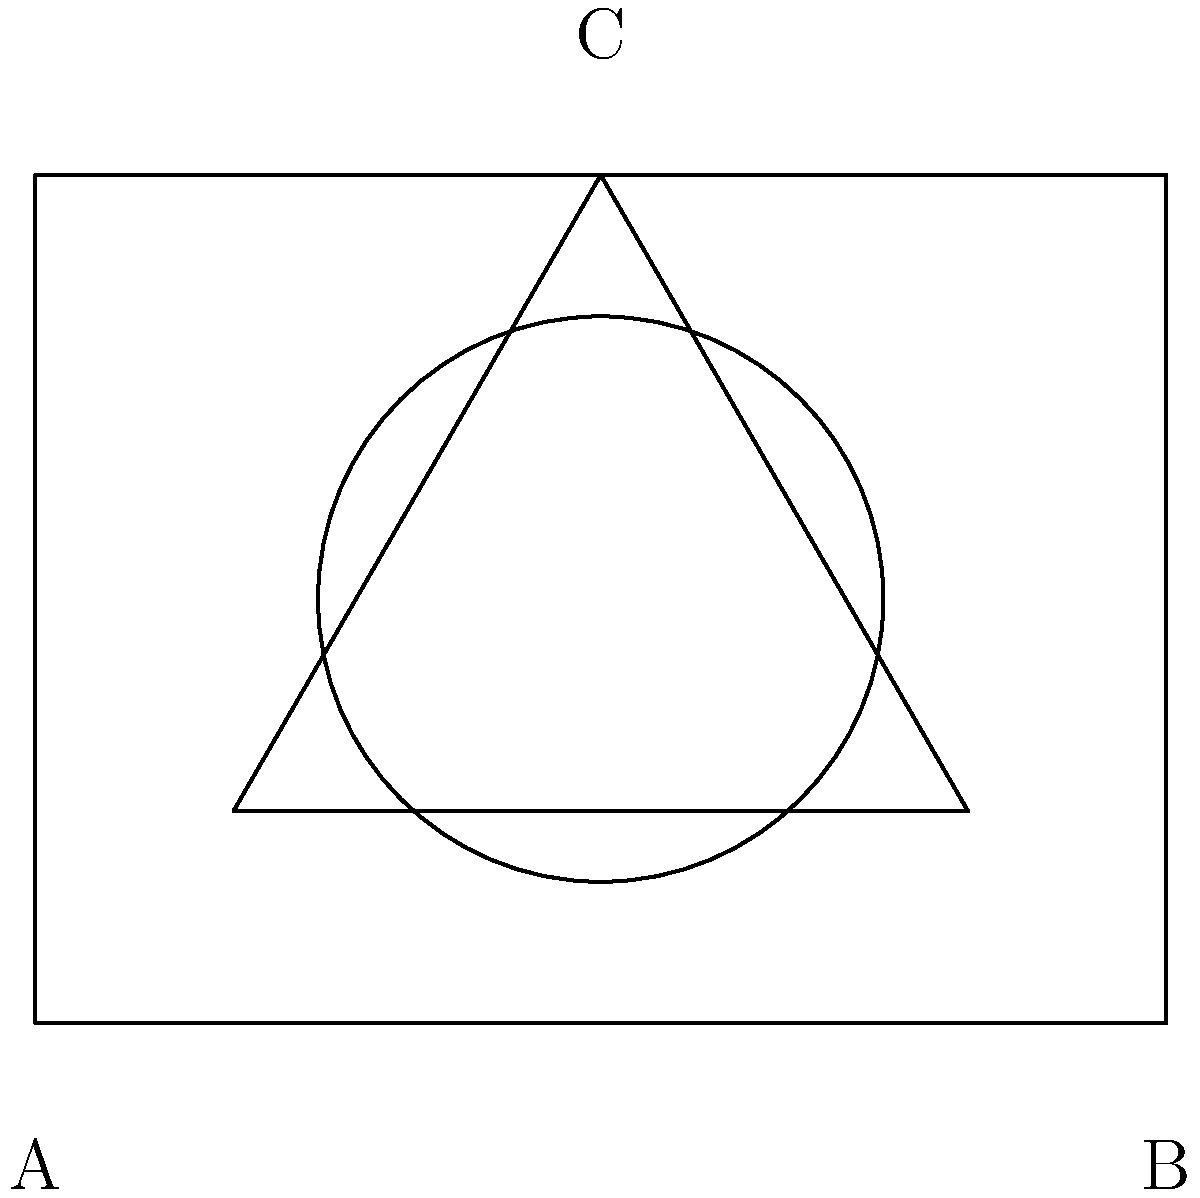In a minimalist storage solution, three geometric shapes are used to represent different storage units: a rectangle (A to B), a circle, and an equilateral triangle (C). If the area of the circular storage unit is $\pi$ square units, what is the total perimeter of all three storage units combined? Let's approach this step-by-step:

1. Rectangle (A to B):
   - Width = 4 units
   - Height = 3 units
   - Perimeter = $2(4 + 3) = 14$ units

2. Circle:
   - Area = $\pi$ sq units
   - Area formula: $A = \pi r^2$
   - So, $\pi = \pi r^2$
   - Radius $r = 1$ unit
   - Circumference = $2\pi r = 2\pi$ units

3. Equilateral Triangle (C):
   - Area of circle = $\pi$ sq units = area of triangle
   - Area of equilateral triangle = $\frac{\sqrt{3}}{4}a^2$, where $a$ is side length
   - So, $\pi = \frac{\sqrt{3}}{4}a^2$
   - $a^2 = \frac{4\pi}{\sqrt{3}}$
   - $a = \sqrt{\frac{4\pi}{\sqrt{3}}} = 2\sqrt{\frac{\pi}{\sqrt{3}}}$
   - Perimeter of triangle = $3a = 6\sqrt{\frac{\pi}{\sqrt{3}}}$

4. Total perimeter:
   Rectangle + Circle + Triangle
   $= 14 + 2\pi + 6\sqrt{\frac{\pi}{\sqrt{3}}}$
Answer: $14 + 2\pi + 6\sqrt{\frac{\pi}{\sqrt{3}}}$ units 